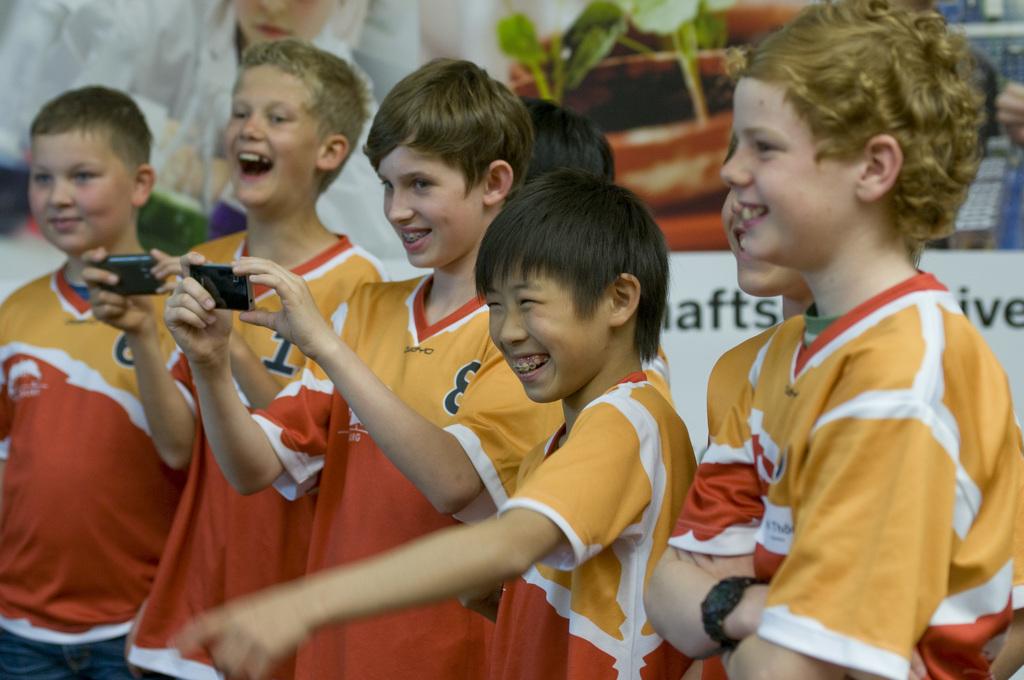What is the number of the blonde child in the middle?
Offer a terse response. 8. 